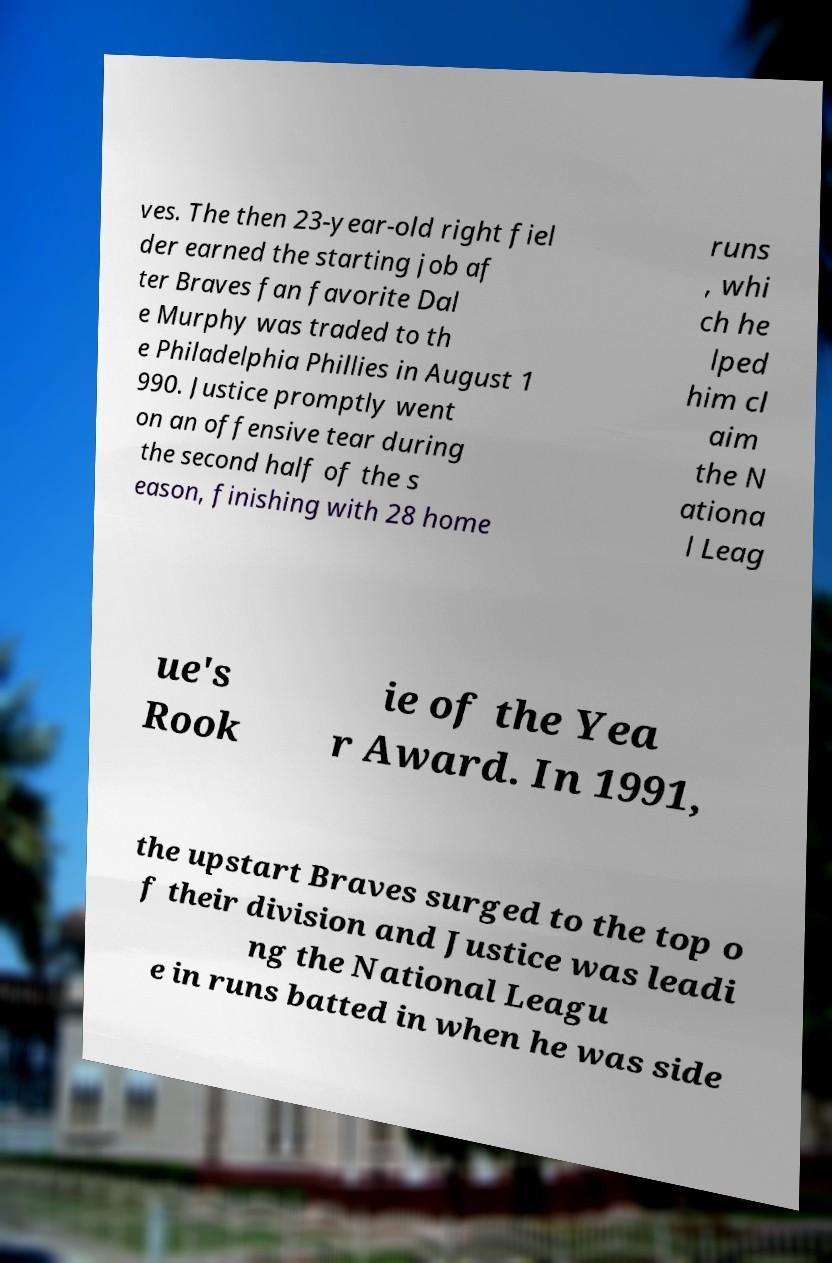Please read and relay the text visible in this image. What does it say? ves. The then 23-year-old right fiel der earned the starting job af ter Braves fan favorite Dal e Murphy was traded to th e Philadelphia Phillies in August 1 990. Justice promptly went on an offensive tear during the second half of the s eason, finishing with 28 home runs , whi ch he lped him cl aim the N ationa l Leag ue's Rook ie of the Yea r Award. In 1991, the upstart Braves surged to the top o f their division and Justice was leadi ng the National Leagu e in runs batted in when he was side 